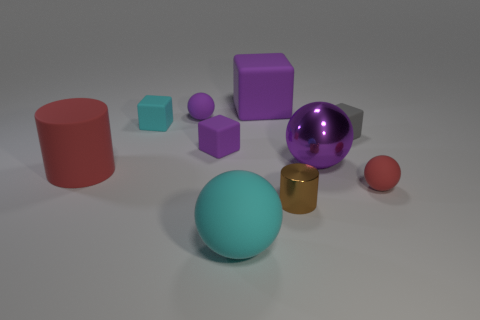Subtract all small purple balls. How many balls are left? 3 Subtract all red balls. How many balls are left? 3 Subtract 1 balls. How many balls are left? 3 Subtract all brown blocks. Subtract all blue balls. How many blocks are left? 4 Subtract all blocks. How many objects are left? 6 Add 9 red cylinders. How many red cylinders are left? 10 Add 2 small purple things. How many small purple things exist? 4 Subtract 0 green spheres. How many objects are left? 10 Subtract all big purple metallic things. Subtract all cubes. How many objects are left? 5 